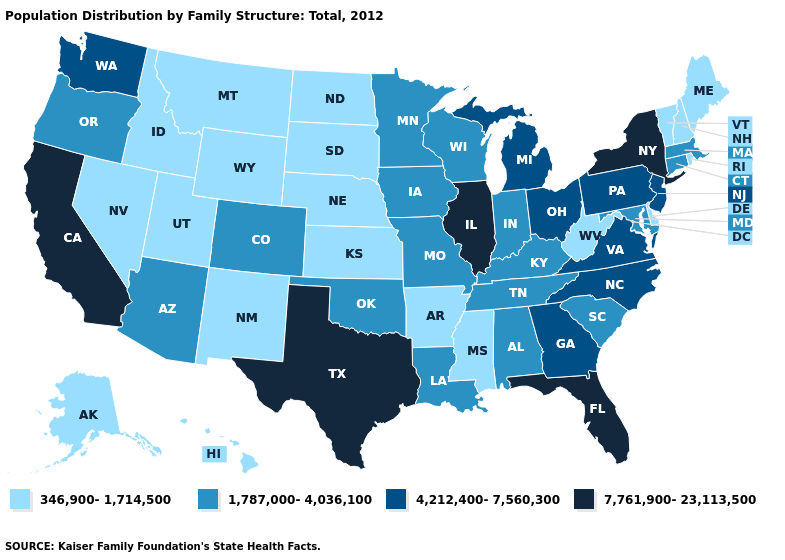What is the value of South Dakota?
Answer briefly. 346,900-1,714,500. Is the legend a continuous bar?
Answer briefly. No. Is the legend a continuous bar?
Short answer required. No. Does Arkansas have a higher value than North Dakota?
Short answer required. No. What is the highest value in the USA?
Concise answer only. 7,761,900-23,113,500. Name the states that have a value in the range 7,761,900-23,113,500?
Be succinct. California, Florida, Illinois, New York, Texas. What is the highest value in the USA?
Give a very brief answer. 7,761,900-23,113,500. What is the value of Vermont?
Write a very short answer. 346,900-1,714,500. Name the states that have a value in the range 1,787,000-4,036,100?
Be succinct. Alabama, Arizona, Colorado, Connecticut, Indiana, Iowa, Kentucky, Louisiana, Maryland, Massachusetts, Minnesota, Missouri, Oklahoma, Oregon, South Carolina, Tennessee, Wisconsin. Which states have the highest value in the USA?
Concise answer only. California, Florida, Illinois, New York, Texas. What is the value of Oklahoma?
Be succinct. 1,787,000-4,036,100. Does Nebraska have the lowest value in the USA?
Write a very short answer. Yes. What is the value of Ohio?
Answer briefly. 4,212,400-7,560,300. What is the value of Arizona?
Give a very brief answer. 1,787,000-4,036,100. 